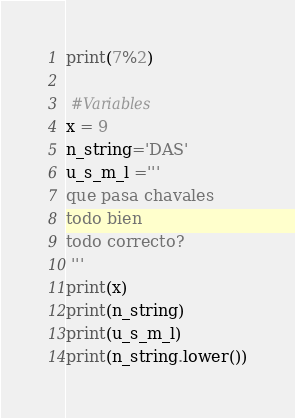Convert code to text. <code><loc_0><loc_0><loc_500><loc_500><_Python_>print(7%2)

 #Variables
x = 9
n_string='DAS'
u_s_m_l ='''
que pasa chavales
todo bien
todo correcto?
 '''
print(x)
print(n_string)
print(u_s_m_l)
print(n_string.lower())</code> 